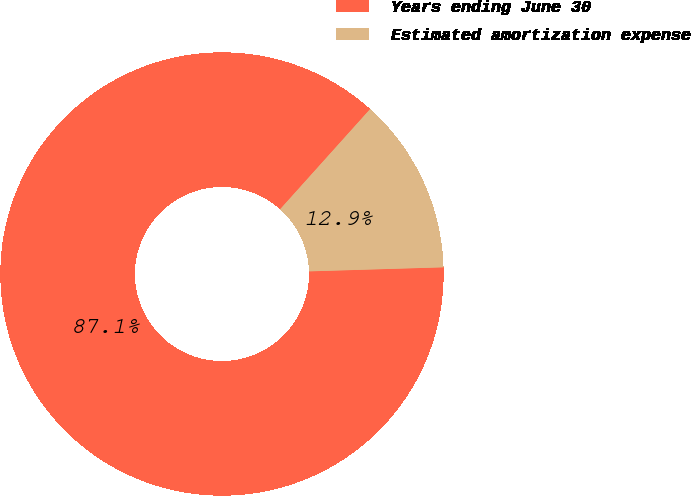Convert chart to OTSL. <chart><loc_0><loc_0><loc_500><loc_500><pie_chart><fcel>Years ending June 30<fcel>Estimated amortization expense<nl><fcel>87.13%<fcel>12.87%<nl></chart> 